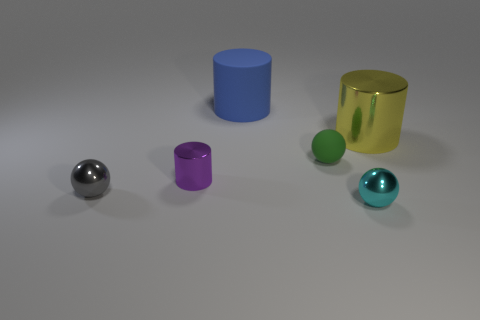Add 3 gray metal cylinders. How many objects exist? 9 Add 6 small blue spheres. How many small blue spheres exist? 6 Subtract 0 cyan cubes. How many objects are left? 6 Subtract all yellow matte things. Subtract all cylinders. How many objects are left? 3 Add 4 cyan metallic objects. How many cyan metallic objects are left? 5 